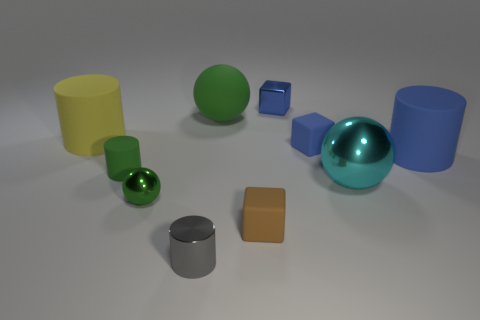Subtract all cylinders. How many objects are left? 6 Subtract 0 yellow spheres. How many objects are left? 10 Subtract all metallic cubes. Subtract all small blue rubber blocks. How many objects are left? 8 Add 7 green balls. How many green balls are left? 9 Add 8 small green shiny blocks. How many small green shiny blocks exist? 8 